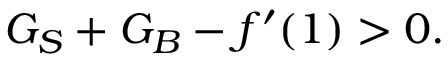<formula> <loc_0><loc_0><loc_500><loc_500>G _ { S } + G _ { B } - f ^ { \prime } ( 1 ) > 0 .</formula> 